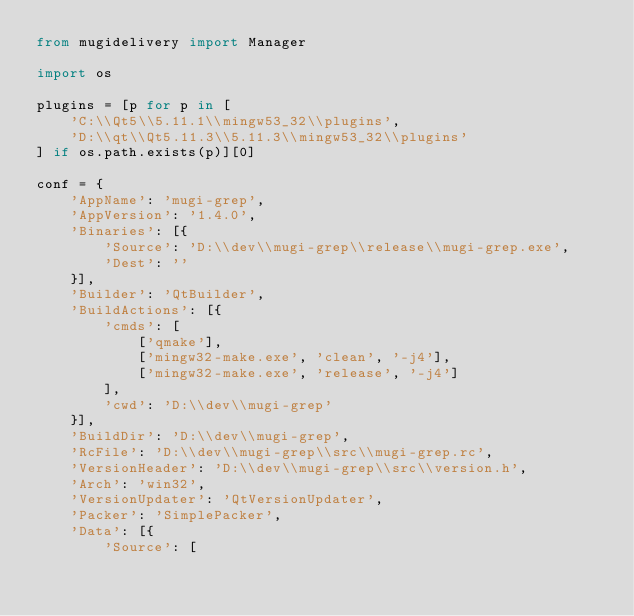Convert code to text. <code><loc_0><loc_0><loc_500><loc_500><_Python_>from mugidelivery import Manager

import os

plugins = [p for p in [
    'C:\\Qt5\\5.11.1\\mingw53_32\\plugins',
    'D:\\qt\\Qt5.11.3\\5.11.3\\mingw53_32\\plugins'
] if os.path.exists(p)][0]

conf = {
    'AppName': 'mugi-grep',
    'AppVersion': '1.4.0',
    'Binaries': [{
        'Source': 'D:\\dev\\mugi-grep\\release\\mugi-grep.exe',
        'Dest': ''
    }],
    'Builder': 'QtBuilder',
    'BuildActions': [{
        'cmds': [
            ['qmake'],
            ['mingw32-make.exe', 'clean', '-j4'],
            ['mingw32-make.exe', 'release', '-j4']
        ],
        'cwd': 'D:\\dev\\mugi-grep'
    }],
    'BuildDir': 'D:\\dev\\mugi-grep',
    'RcFile': 'D:\\dev\\mugi-grep\\src\\mugi-grep.rc',
    'VersionHeader': 'D:\\dev\\mugi-grep\\src\\version.h',
    'Arch': 'win32',
    'VersionUpdater': 'QtVersionUpdater',
    'Packer': 'SimplePacker',
    'Data': [{
        'Source': [</code> 